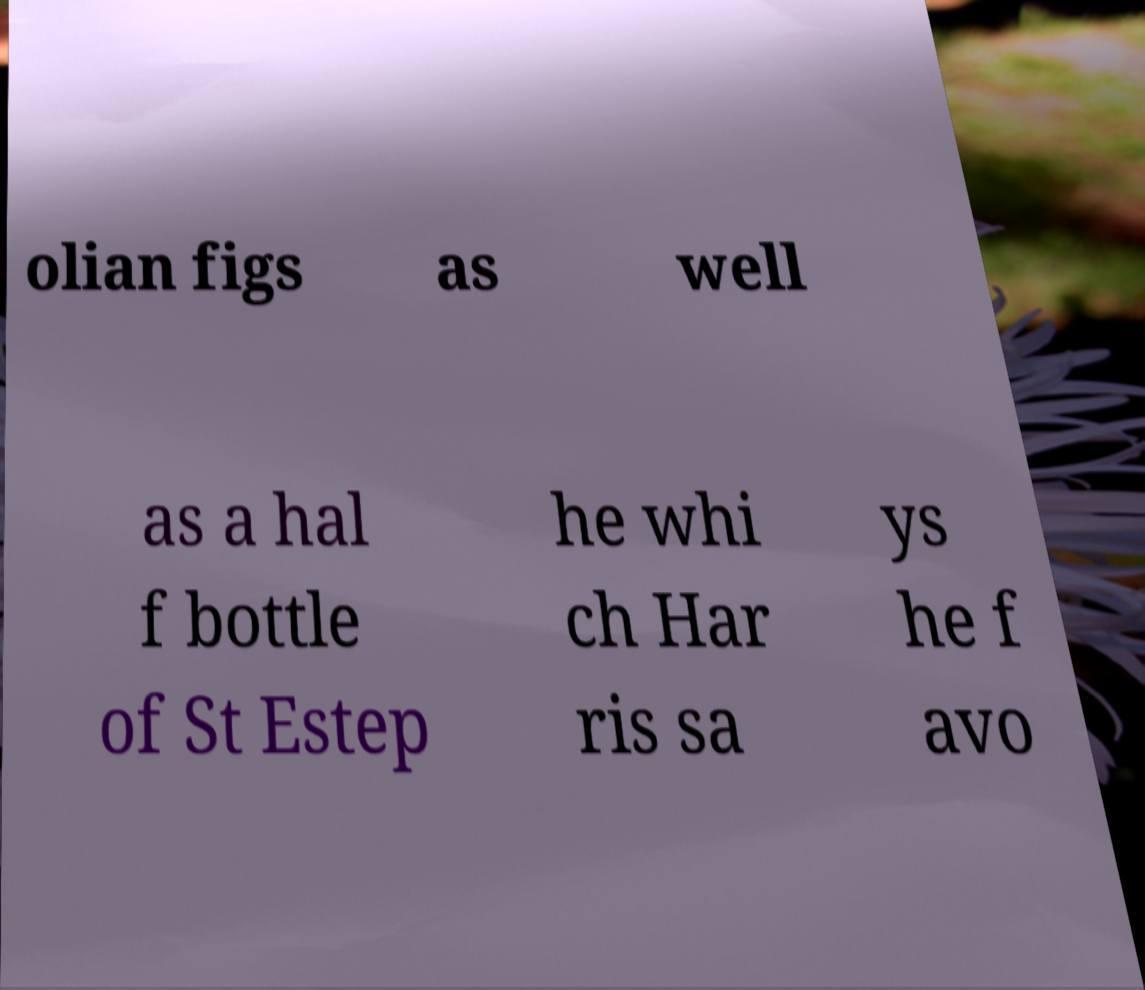For documentation purposes, I need the text within this image transcribed. Could you provide that? olian figs as well as a hal f bottle of St Estep he whi ch Har ris sa ys he f avo 